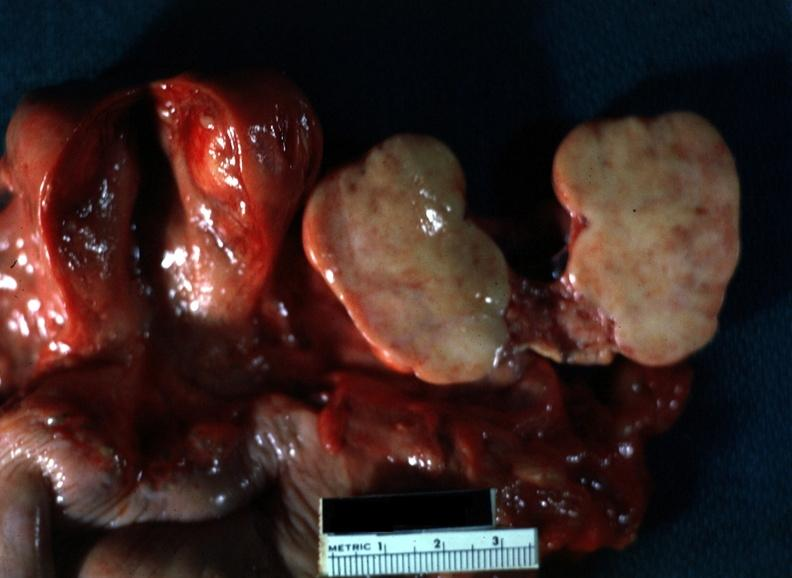s myocardial infarct present?
Answer the question using a single word or phrase. No 